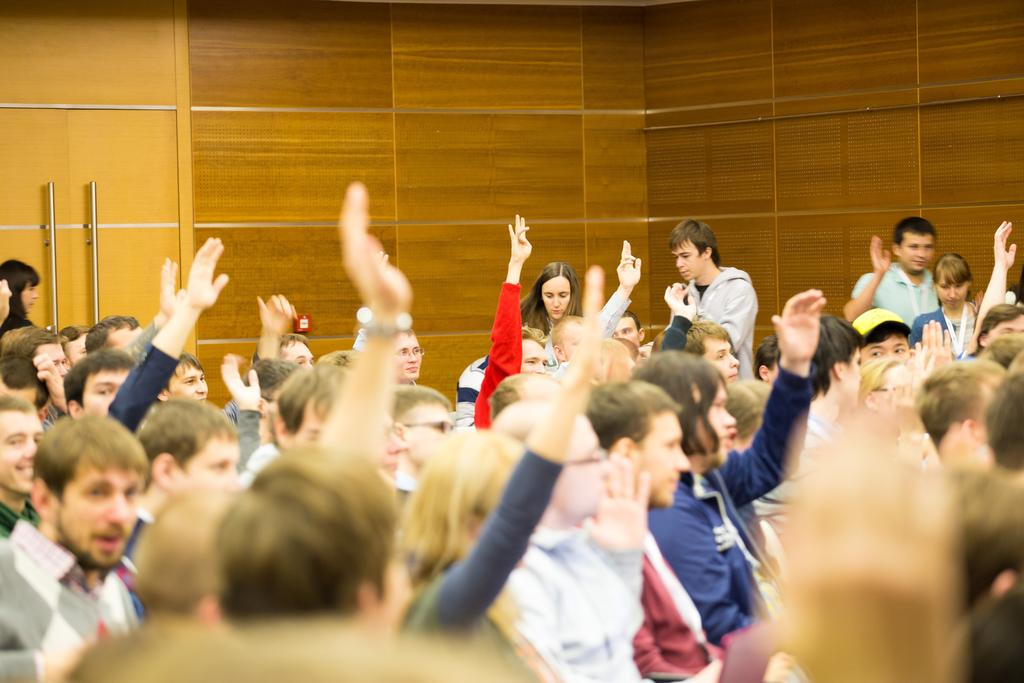Who or what is present in the image? There are people in the image. What are the people doing in the image? Some of the people are raising their hands. What can be seen in the background of the image? There is a wall in the image. Are there any specific features on the wall? There are doors in the image. What can be used to open the doors? There are handles in the image. What language is the actor speaking in the image? There is no actor present in the image, and therefore no language can be attributed to them. 